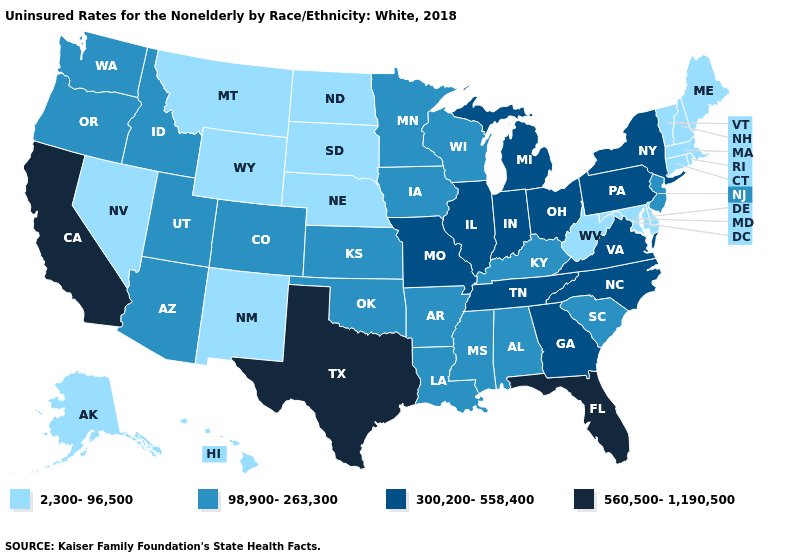What is the value of Tennessee?
Give a very brief answer. 300,200-558,400. Does Texas have the highest value in the South?
Give a very brief answer. Yes. What is the value of Illinois?
Answer briefly. 300,200-558,400. Does South Dakota have the same value as Missouri?
Short answer required. No. Does Kansas have a higher value than South Dakota?
Concise answer only. Yes. Name the states that have a value in the range 98,900-263,300?
Answer briefly. Alabama, Arizona, Arkansas, Colorado, Idaho, Iowa, Kansas, Kentucky, Louisiana, Minnesota, Mississippi, New Jersey, Oklahoma, Oregon, South Carolina, Utah, Washington, Wisconsin. Name the states that have a value in the range 2,300-96,500?
Write a very short answer. Alaska, Connecticut, Delaware, Hawaii, Maine, Maryland, Massachusetts, Montana, Nebraska, Nevada, New Hampshire, New Mexico, North Dakota, Rhode Island, South Dakota, Vermont, West Virginia, Wyoming. Does Arizona have the lowest value in the West?
Answer briefly. No. What is the lowest value in the USA?
Short answer required. 2,300-96,500. Does the map have missing data?
Concise answer only. No. What is the value of Indiana?
Answer briefly. 300,200-558,400. What is the value of Alaska?
Concise answer only. 2,300-96,500. What is the lowest value in states that border Texas?
Be succinct. 2,300-96,500. What is the lowest value in states that border Missouri?
Give a very brief answer. 2,300-96,500. 